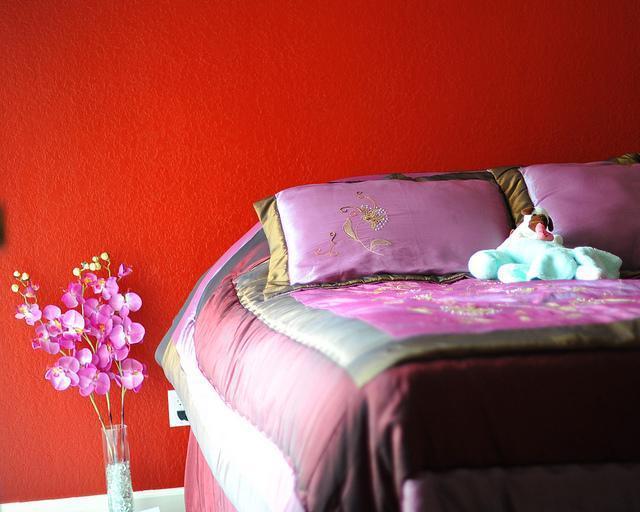How many giraffes are facing to the right?
Give a very brief answer. 0. 